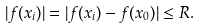<formula> <loc_0><loc_0><loc_500><loc_500>| f ( x _ { i } ) | = | f ( x _ { i } ) - f ( x _ { 0 } ) | \leq R .</formula> 